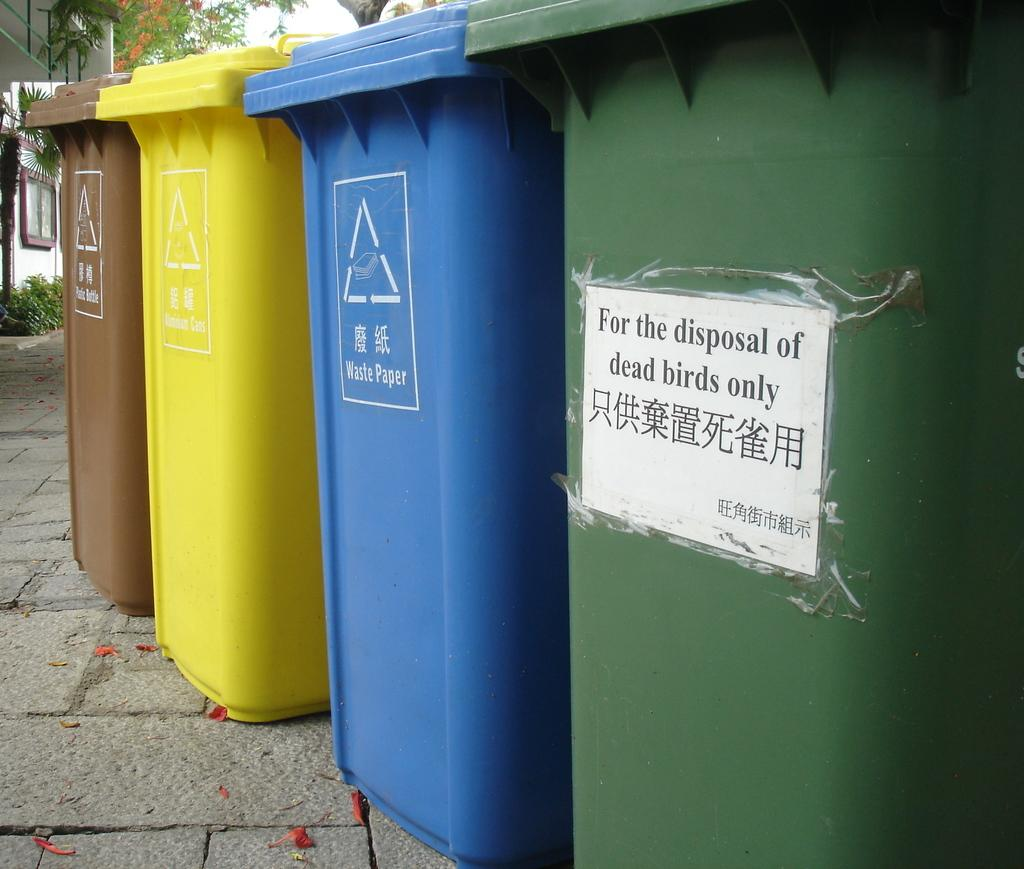<image>
Render a clear and concise summary of the photo. A trash can on a side walk has a sign on it marking it for dead birds only. 